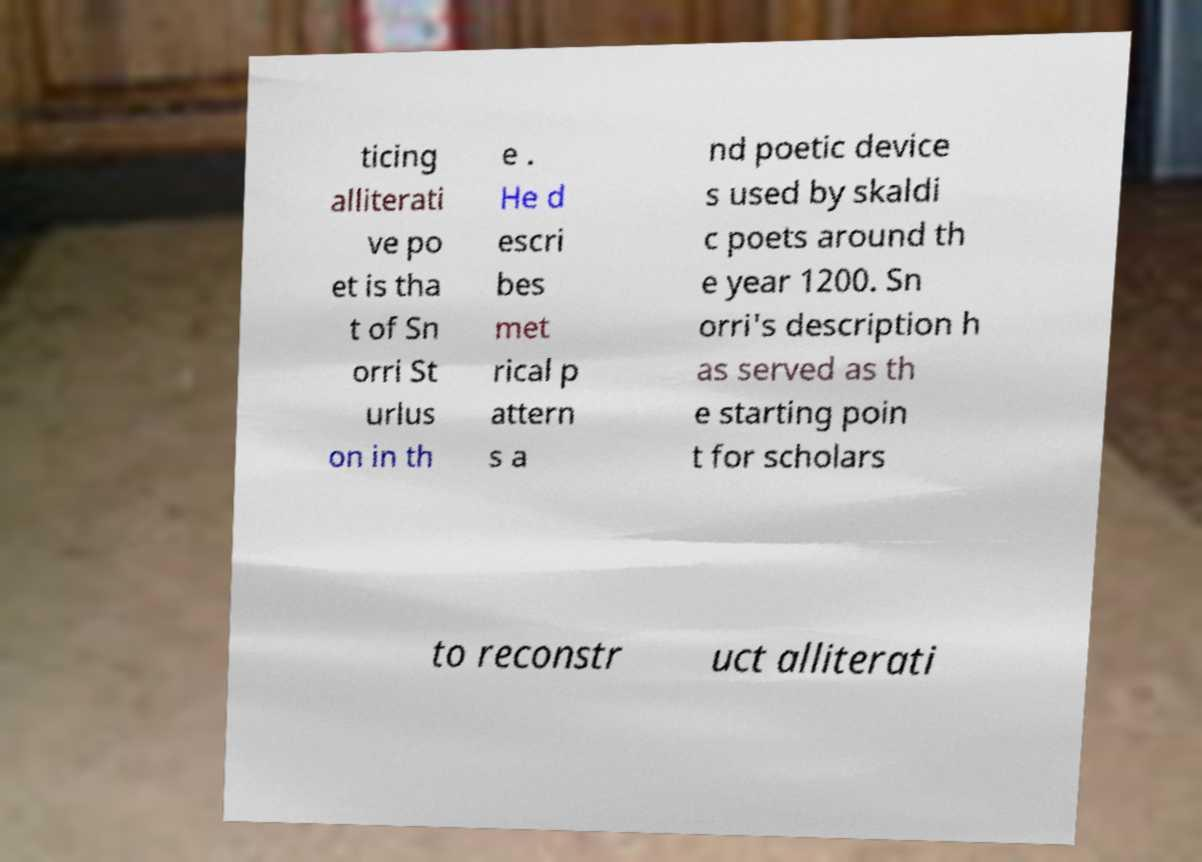Can you read and provide the text displayed in the image?This photo seems to have some interesting text. Can you extract and type it out for me? ticing alliterati ve po et is tha t of Sn orri St urlus on in th e . He d escri bes met rical p attern s a nd poetic device s used by skaldi c poets around th e year 1200. Sn orri's description h as served as th e starting poin t for scholars to reconstr uct alliterati 